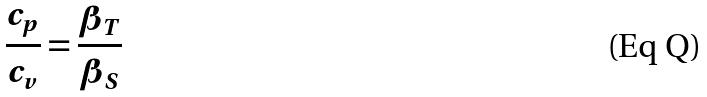<formula> <loc_0><loc_0><loc_500><loc_500>\frac { c _ { p } } { c _ { v } } = \frac { \beta _ { T } } { \beta _ { S } }</formula> 